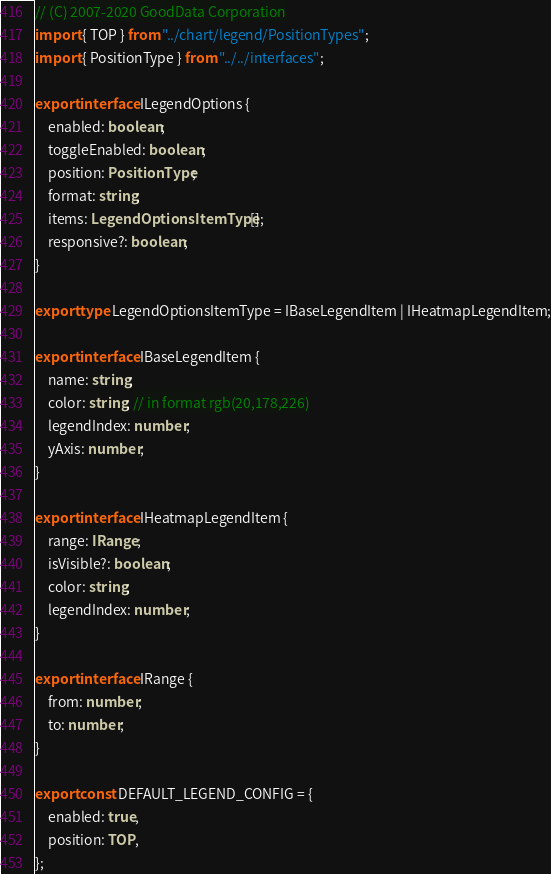<code> <loc_0><loc_0><loc_500><loc_500><_TypeScript_>// (C) 2007-2020 GoodData Corporation
import { TOP } from "../chart/legend/PositionTypes";
import { PositionType } from "../../interfaces";

export interface ILegendOptions {
    enabled: boolean;
    toggleEnabled: boolean;
    position: PositionType;
    format: string;
    items: LegendOptionsItemType[];
    responsive?: boolean;
}

export type LegendOptionsItemType = IBaseLegendItem | IHeatmapLegendItem;

export interface IBaseLegendItem {
    name: string;
    color: string; // in format rgb(20,178,226)
    legendIndex: number;
    yAxis: number;
}

export interface IHeatmapLegendItem {
    range: IRange;
    isVisible?: boolean;
    color: string;
    legendIndex: number;
}

export interface IRange {
    from: number;
    to: number;
}

export const DEFAULT_LEGEND_CONFIG = {
    enabled: true,
    position: TOP,
};
</code> 